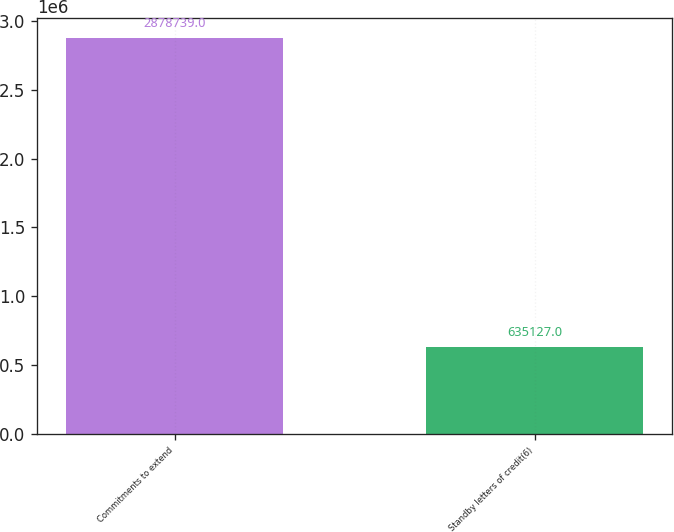Convert chart to OTSL. <chart><loc_0><loc_0><loc_500><loc_500><bar_chart><fcel>Commitments to extend<fcel>Standby letters of credit(6)<nl><fcel>2.87874e+06<fcel>635127<nl></chart> 